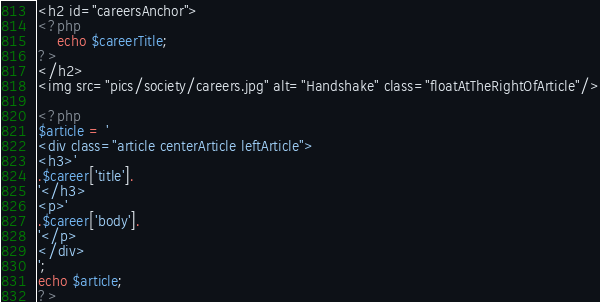Convert code to text. <code><loc_0><loc_0><loc_500><loc_500><_PHP_><h2 id="careersAnchor">
<?php
	echo $careerTitle;
?>
</h2>
<img src="pics/society/careers.jpg" alt="Handshake" class="floatAtTheRightOfArticle"/>

<?php
$article = '		
<div class="article centerArticle leftArticle">
<h3>'
.$career['title'].
'</h3>
<p>'
.$career['body'].
'</p>
</div>
';
echo $article;
?></code> 